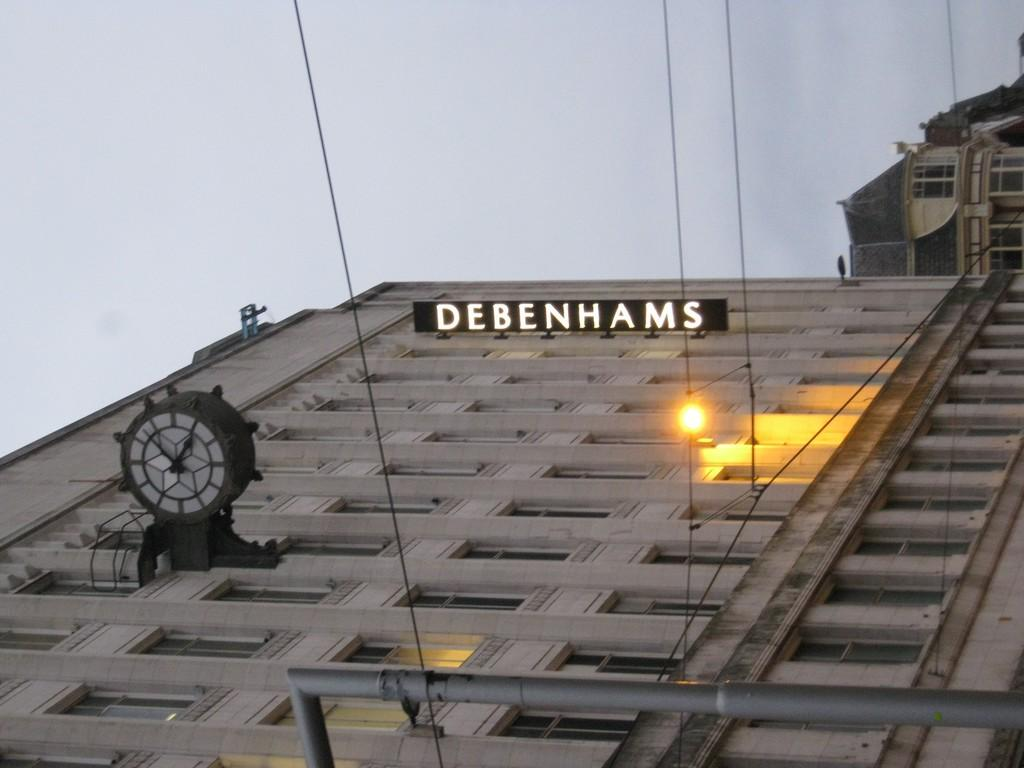What type of structures are present in the image? There are buildings in the image. Can you describe any specific features on the buildings? Yes, there is a clock on one of the buildings, and there is a name board on the building with the clock. What else can be seen in the image besides the buildings? There is a light visible in the image, as well as a pole and wires. What is visible in the background of the image? The sky is visible in the background of the image. What type of credit can be seen being offered on the roof of the building in the image? There is no credit being offered on the roof of the building in the image. What type of lead is being used to connect the wires in the image? There is no lead visible in the image; only wires are present. 